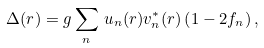Convert formula to latex. <formula><loc_0><loc_0><loc_500><loc_500>\Delta ( { r } ) = g \sum _ { n } \, u _ { n } ( { r } ) v _ { n } ^ { * } ( { r } ) \left ( 1 - 2 f _ { n } \right ) ,</formula> 